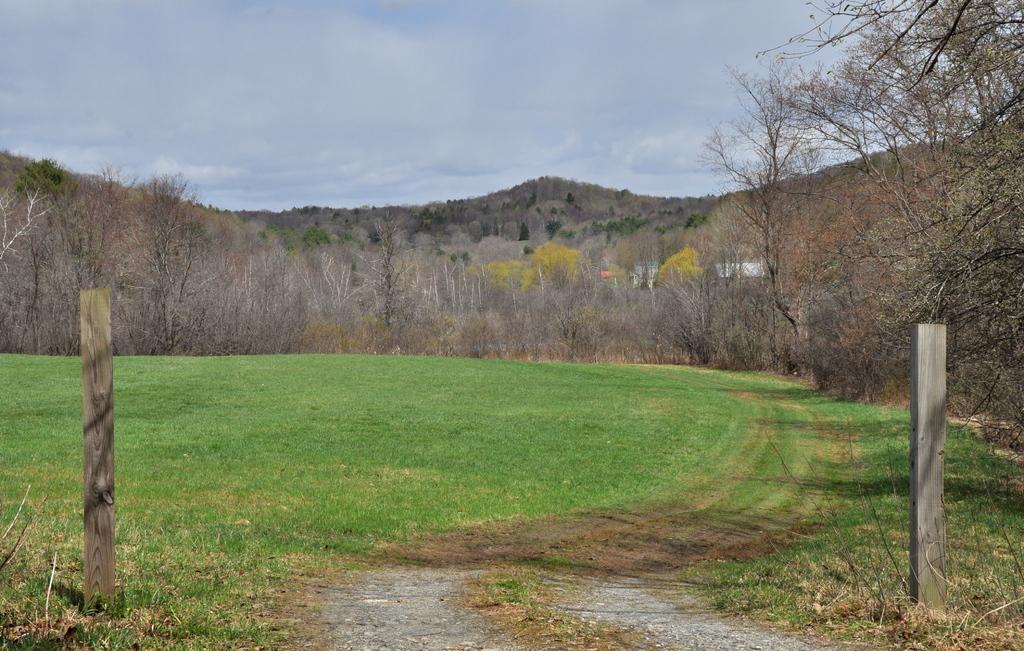Please provide a concise description of this image. In this image I can see an open grass ground and in the front I can see two wooden poles. In the background I can see number of trees, few buildings, clouds and the sky. 